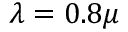Convert formula to latex. <formula><loc_0><loc_0><loc_500><loc_500>\lambda = 0 . 8 \mu</formula> 